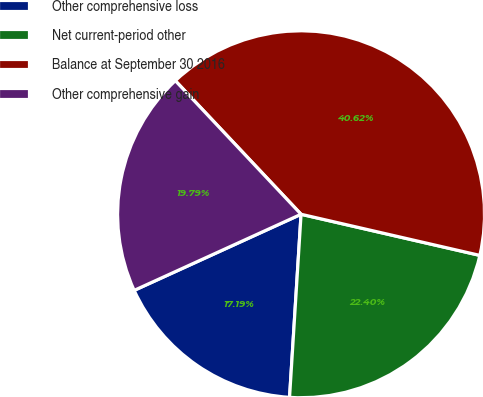Convert chart to OTSL. <chart><loc_0><loc_0><loc_500><loc_500><pie_chart><fcel>Other comprehensive loss<fcel>Net current-period other<fcel>Balance at September 30 2016<fcel>Other comprehensive gain<nl><fcel>17.19%<fcel>22.4%<fcel>40.62%<fcel>19.79%<nl></chart> 